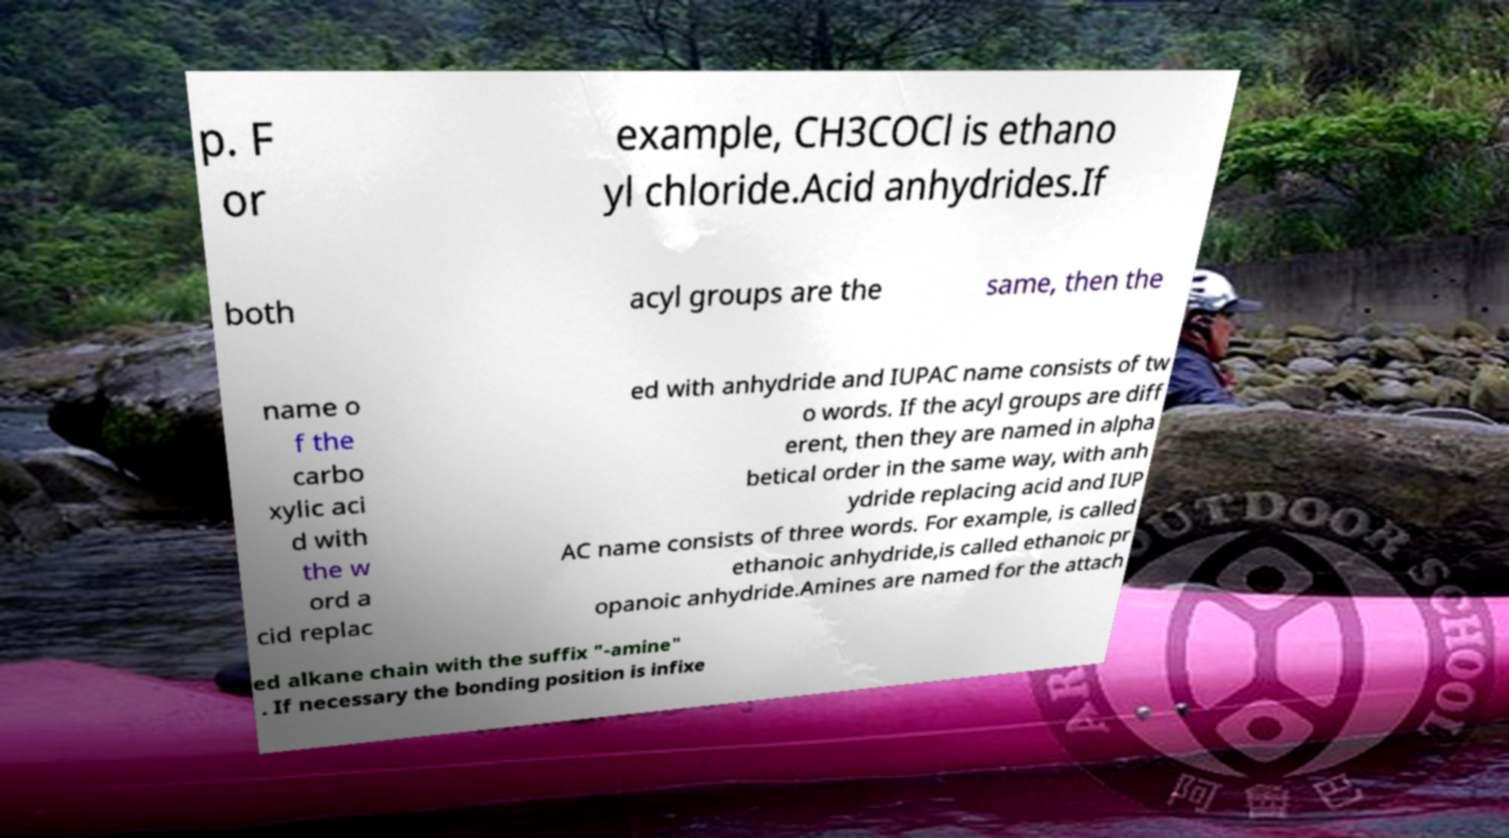What messages or text are displayed in this image? I need them in a readable, typed format. p. F or example, CH3COCl is ethano yl chloride.Acid anhydrides.If both acyl groups are the same, then the name o f the carbo xylic aci d with the w ord a cid replac ed with anhydride and IUPAC name consists of tw o words. If the acyl groups are diff erent, then they are named in alpha betical order in the same way, with anh ydride replacing acid and IUP AC name consists of three words. For example, is called ethanoic anhydride,is called ethanoic pr opanoic anhydride.Amines are named for the attach ed alkane chain with the suffix "-amine" . If necessary the bonding position is infixe 